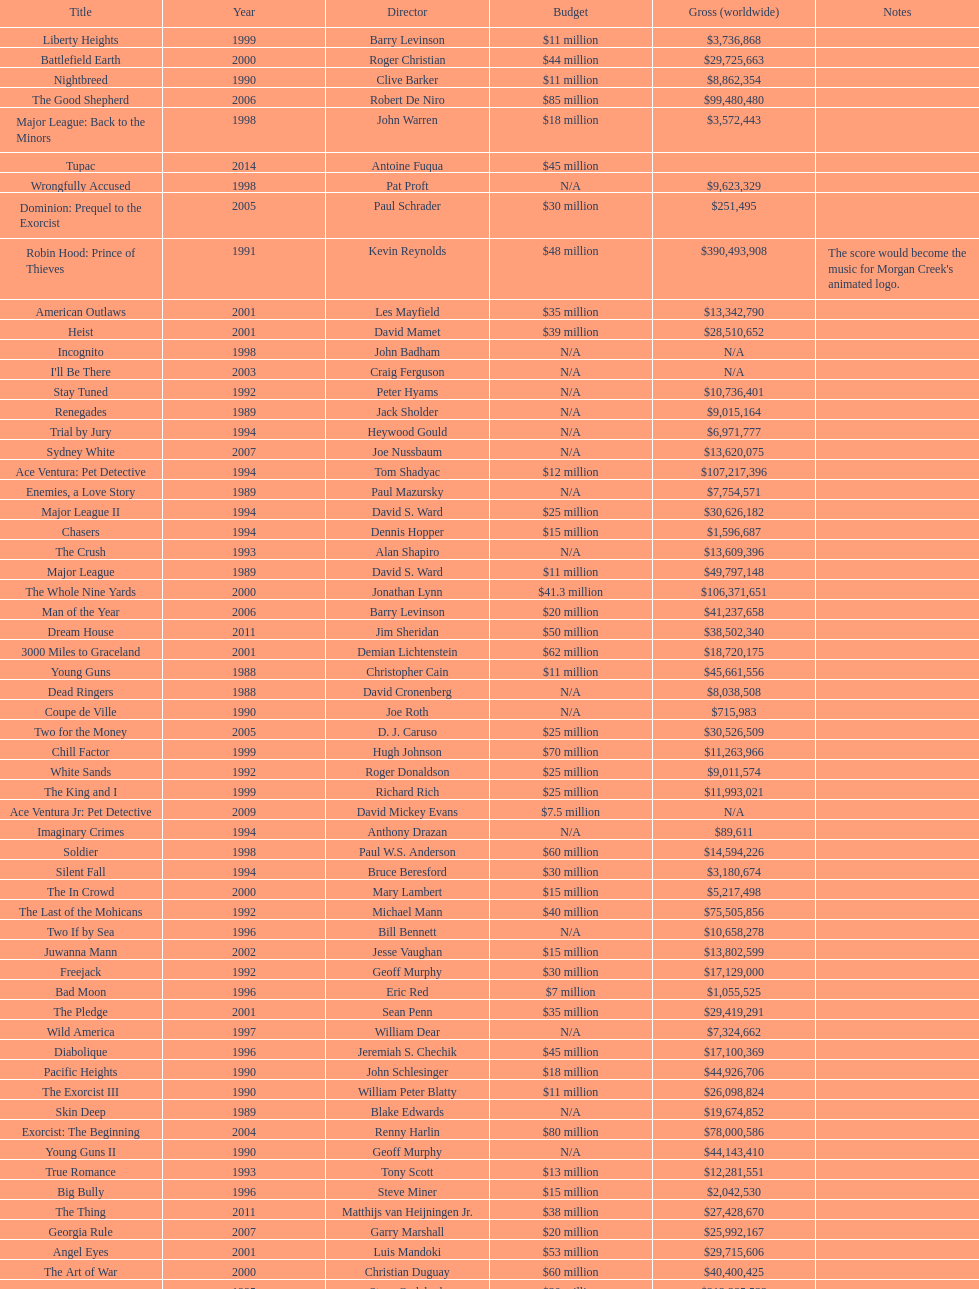What movie came out after bad moon? Wild America. 